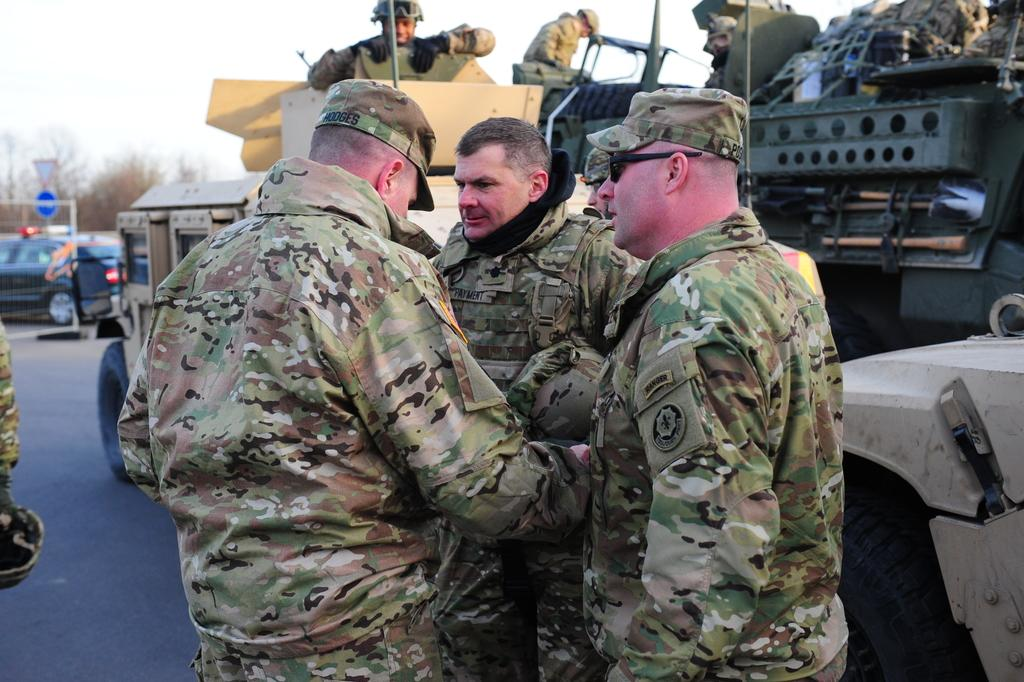How many soldiers are in the image? There are three soldiers in the foreground of the image. What are the soldiers doing in the image? The soldiers are standing in the image. What can be seen in the background of the image? There are heavy vehicles in the background of the image. Where is the mom in the image? There is no mom present in the image. What type of bushes can be seen in the image? There are no bushes visible in the image. 